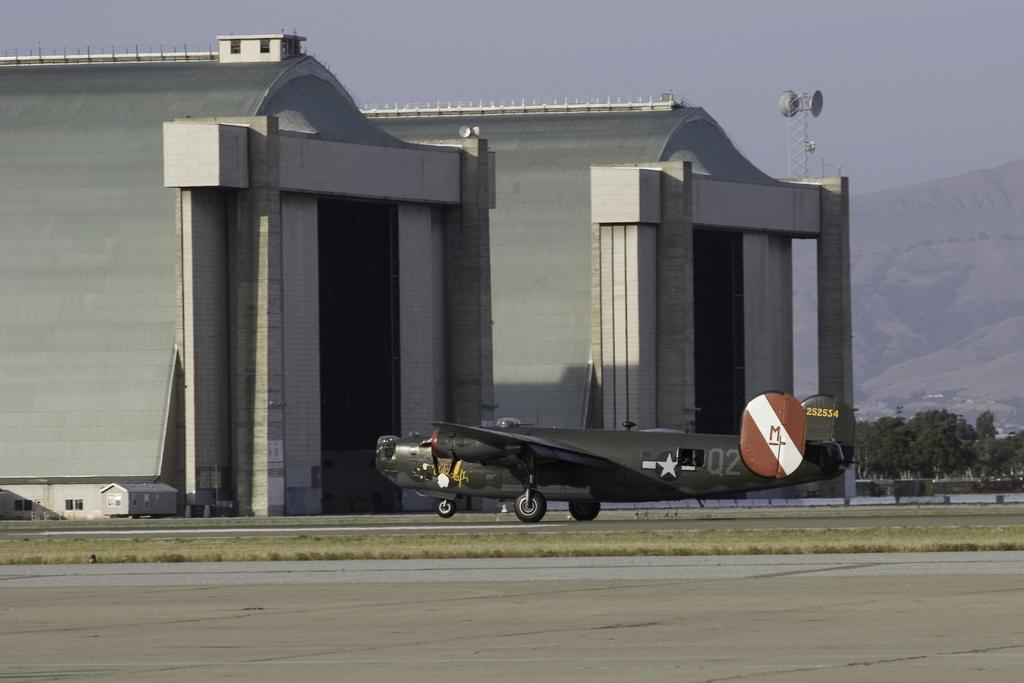What type of structure is present in the image? There is a building in the image. What is located on the ground near the building? There is an airplane on the ground in the image. What type of natural features can be seen in the image? There are trees and mountains in the image. What is the purpose of the tall, thin structure in the image? There is an antenna in the image, which is likely used for communication or broadcasting. What is visible in the sky in the image? The sky is visible in the image. How many wrens can be seen flying around the airplane in the image? There are no wrens present in the image. What type of test is being conducted on the building in the image? There is no test being conducted on the building in the image. 